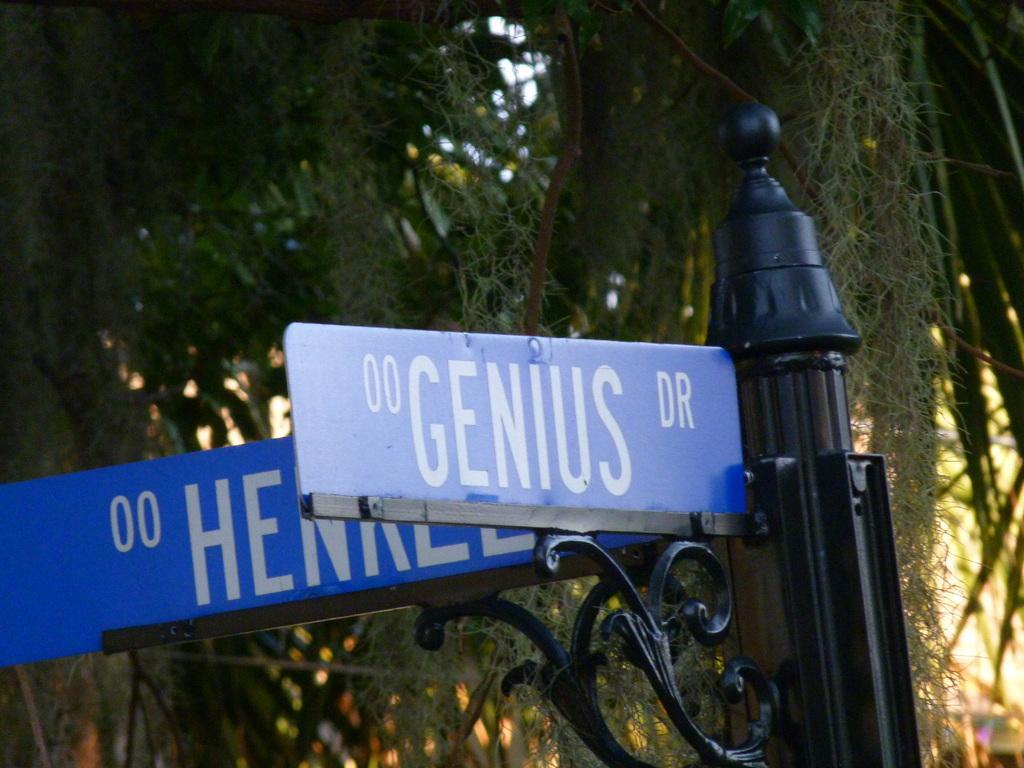Please provide a concise description of this image. In this image we can see two sign board and one black color pole. Behind trees are there. 